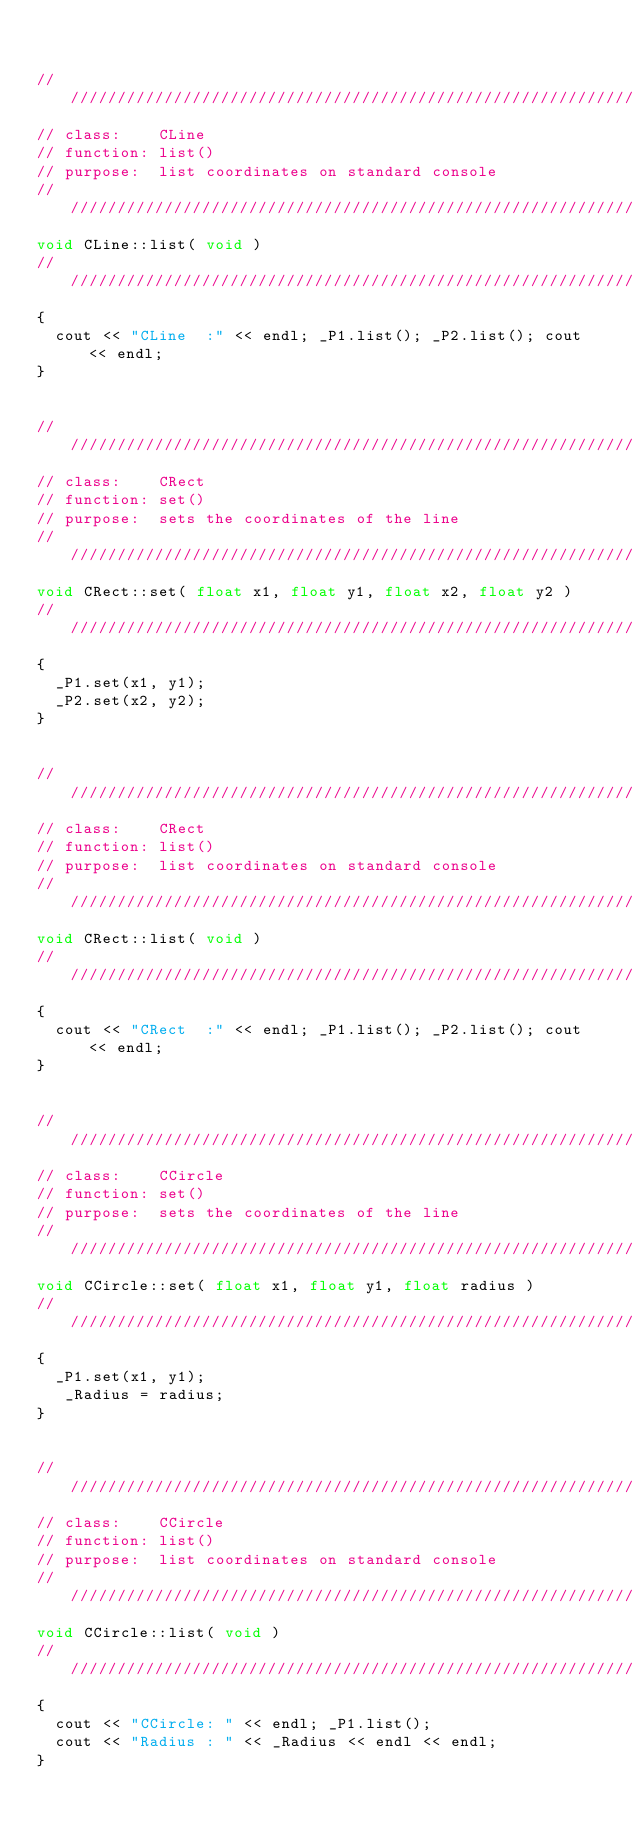Convert code to text. <code><loc_0><loc_0><loc_500><loc_500><_C++_>

///////////////////////////////////////////////////////////////////////////////
// class:    CLine
// function: list()
// purpose:  list coordinates on standard console
///////////////////////////////////////////////////////////////////////////////
void CLine::list( void )
///////////////////////////////////////////////////////////////////////////////
{
	cout << "CLine  :" << endl; _P1.list(); _P2.list(); cout << endl;
}


///////////////////////////////////////////////////////////////////////////////
// class:    CRect
// function: set()
// purpose:  sets the coordinates of the line
///////////////////////////////////////////////////////////////////////////////
void CRect::set( float x1, float y1, float x2, float y2 )
///////////////////////////////////////////////////////////////////////////////
{
	_P1.set(x1, y1);
	_P2.set(x2, y2);
}


///////////////////////////////////////////////////////////////////////////////
// class:    CRect
// function: list()
// purpose:  list coordinates on standard console
///////////////////////////////////////////////////////////////////////////////
void CRect::list( void )
///////////////////////////////////////////////////////////////////////////////
{
	cout << "CRect  :" << endl; _P1.list(); _P2.list(); cout << endl;
}


///////////////////////////////////////////////////////////////////////////////
// class:    CCircle
// function: set()
// purpose:  sets the coordinates of the line
///////////////////////////////////////////////////////////////////////////////
void CCircle::set( float x1, float y1, float radius )
///////////////////////////////////////////////////////////////////////////////
{
	_P1.set(x1, y1);
   _Radius = radius;
}


///////////////////////////////////////////////////////////////////////////////
// class:    CCircle
// function: list()
// purpose:  list coordinates on standard console
///////////////////////////////////////////////////////////////////////////////
void CCircle::list( void )
///////////////////////////////////////////////////////////////////////////////
{
	cout << "CCircle: " << endl; _P1.list();
	cout << "Radius : " << _Radius << endl << endl;
}
</code> 